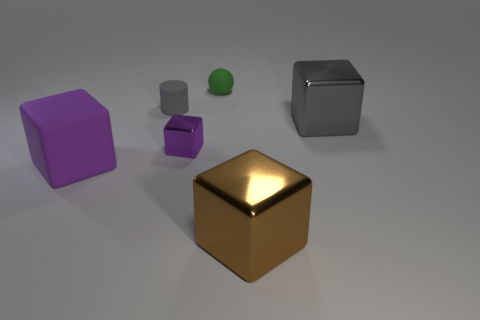Subtract all purple shiny blocks. How many blocks are left? 3 Add 3 tiny gray matte blocks. How many objects exist? 9 Subtract 0 cyan blocks. How many objects are left? 6 Subtract all blocks. How many objects are left? 2 Subtract 1 cylinders. How many cylinders are left? 0 Subtract all blue cylinders. Subtract all red blocks. How many cylinders are left? 1 Subtract all red spheres. How many brown cubes are left? 1 Subtract all tiny matte objects. Subtract all big brown shiny objects. How many objects are left? 3 Add 6 shiny blocks. How many shiny blocks are left? 9 Add 5 small red metal cylinders. How many small red metal cylinders exist? 5 